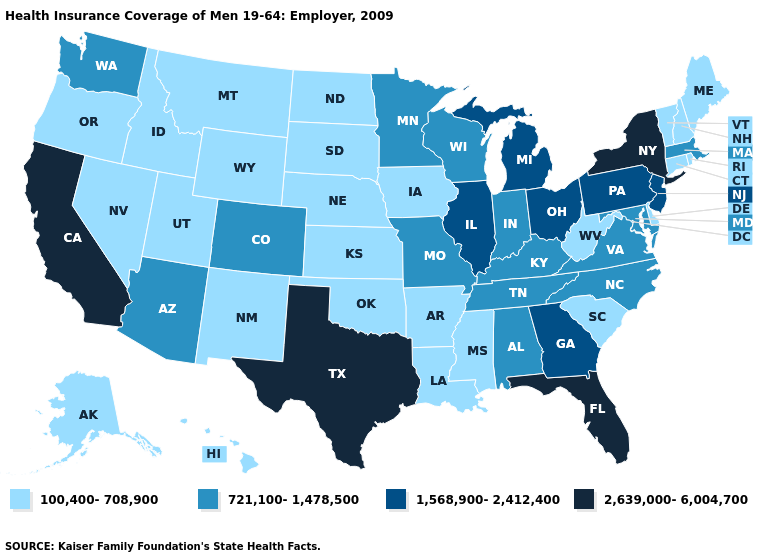What is the lowest value in the USA?
Keep it brief. 100,400-708,900. Does New Hampshire have the highest value in the USA?
Answer briefly. No. What is the value of Missouri?
Give a very brief answer. 721,100-1,478,500. What is the lowest value in states that border Pennsylvania?
Answer briefly. 100,400-708,900. Does South Dakota have the same value as Mississippi?
Quick response, please. Yes. What is the highest value in the USA?
Concise answer only. 2,639,000-6,004,700. What is the value of West Virginia?
Short answer required. 100,400-708,900. Does Wisconsin have a higher value than California?
Short answer required. No. What is the highest value in states that border California?
Keep it brief. 721,100-1,478,500. Does Florida have the highest value in the USA?
Quick response, please. Yes. What is the value of Maryland?
Short answer required. 721,100-1,478,500. Among the states that border Montana , which have the lowest value?
Answer briefly. Idaho, North Dakota, South Dakota, Wyoming. Does Wyoming have the highest value in the USA?
Be succinct. No. Does North Carolina have the lowest value in the South?
Keep it brief. No. 